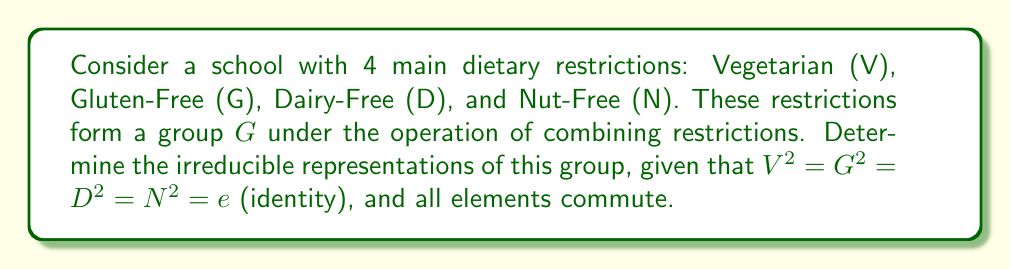Give your solution to this math problem. 1) First, we need to identify the structure of the group. Since all elements commute and square to the identity, this is an abelian group isomorphic to $\mathbb{Z}_2 \times \mathbb{Z}_2 \times \mathbb{Z}_2 \times \mathbb{Z}_2$.

2) For abelian groups, all irreducible representations are one-dimensional. The number of irreducible representations equals the order of the group.

3) The order of the group is $|G| = 2^4 = 16$, so there are 16 irreducible representations.

4) Each irreducible representation $\rho_i$ is determined by its values on the generators V, G, D, and N:

   $\rho_i(V), \rho_i(G), \rho_i(D), \rho_i(N) \in \{1, -1\}$

5) The 16 irreducible representations are:

   $$\begin{array}{cccc}
   \rho_1: & (1,1,1,1) & \rho_9: & (1,1,-1,-1) \\
   \rho_2: & (-1,1,1,1) & \rho_{10}: & (-1,1,-1,-1) \\
   \rho_3: & (1,-1,1,1) & \rho_{11}: & (1,-1,-1,-1) \\
   \rho_4: & (1,1,-1,1) & \rho_{12}: & (-1,-1,-1,-1) \\
   \rho_5: & (1,1,1,-1) & \rho_{13}: & (-1,-1,1,-1) \\
   \rho_6: & (-1,-1,1,1) & \rho_{14}: & (-1,-1,-1,1) \\
   \rho_7: & (-1,1,-1,1) & \rho_{15}: & (-1,1,1,-1) \\
   \rho_8: & (-1,1,1,-1) & \rho_{16}: & (1,-1,1,-1)
   \end{array}$$

   where each tuple $(a,b,c,d)$ represents $(\rho_i(V), \rho_i(G), \rho_i(D), \rho_i(N))$.

6) These representations are irreducible because they cannot be further decomposed, and they form a complete set of representations for the group.
Answer: 16 one-dimensional representations: $\rho_i(V,G,D,N) = (\pm1,\pm1,\pm1,\pm1)$ 